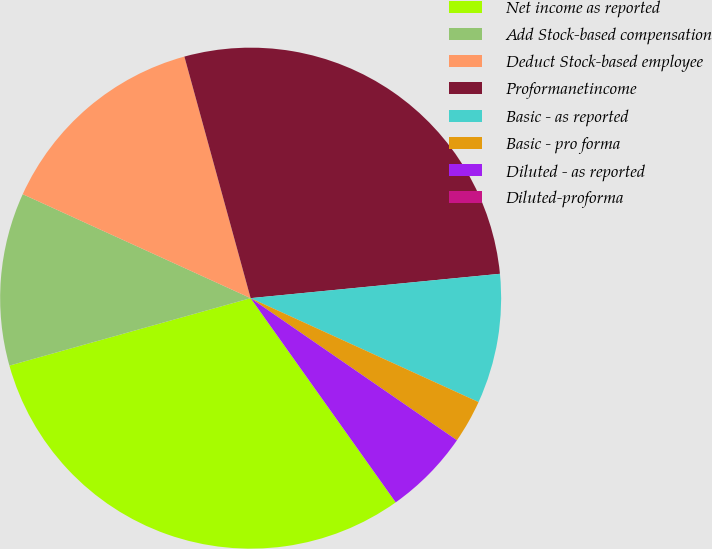<chart> <loc_0><loc_0><loc_500><loc_500><pie_chart><fcel>Net income as reported<fcel>Add Stock-based compensation<fcel>Deduct Stock-based employee<fcel>Proformanetincome<fcel>Basic - as reported<fcel>Basic - pro forma<fcel>Diluted - as reported<fcel>Diluted-proforma<nl><fcel>30.49%<fcel>11.15%<fcel>13.93%<fcel>27.71%<fcel>8.36%<fcel>2.79%<fcel>5.57%<fcel>0.0%<nl></chart> 